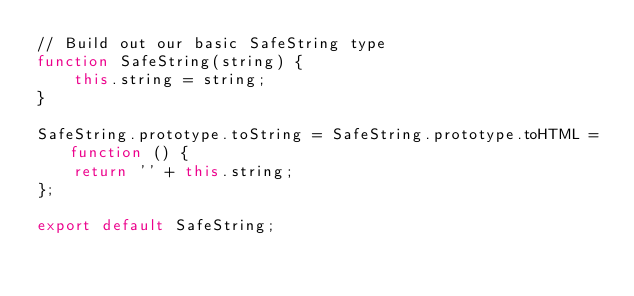Convert code to text. <code><loc_0><loc_0><loc_500><loc_500><_JavaScript_>// Build out our basic SafeString type
function SafeString(string) {
    this.string = string;
}

SafeString.prototype.toString = SafeString.prototype.toHTML = function () {
    return '' + this.string;
};

export default SafeString;
</code> 